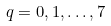Convert formula to latex. <formula><loc_0><loc_0><loc_500><loc_500>q = 0 , 1 , \dots , 7</formula> 